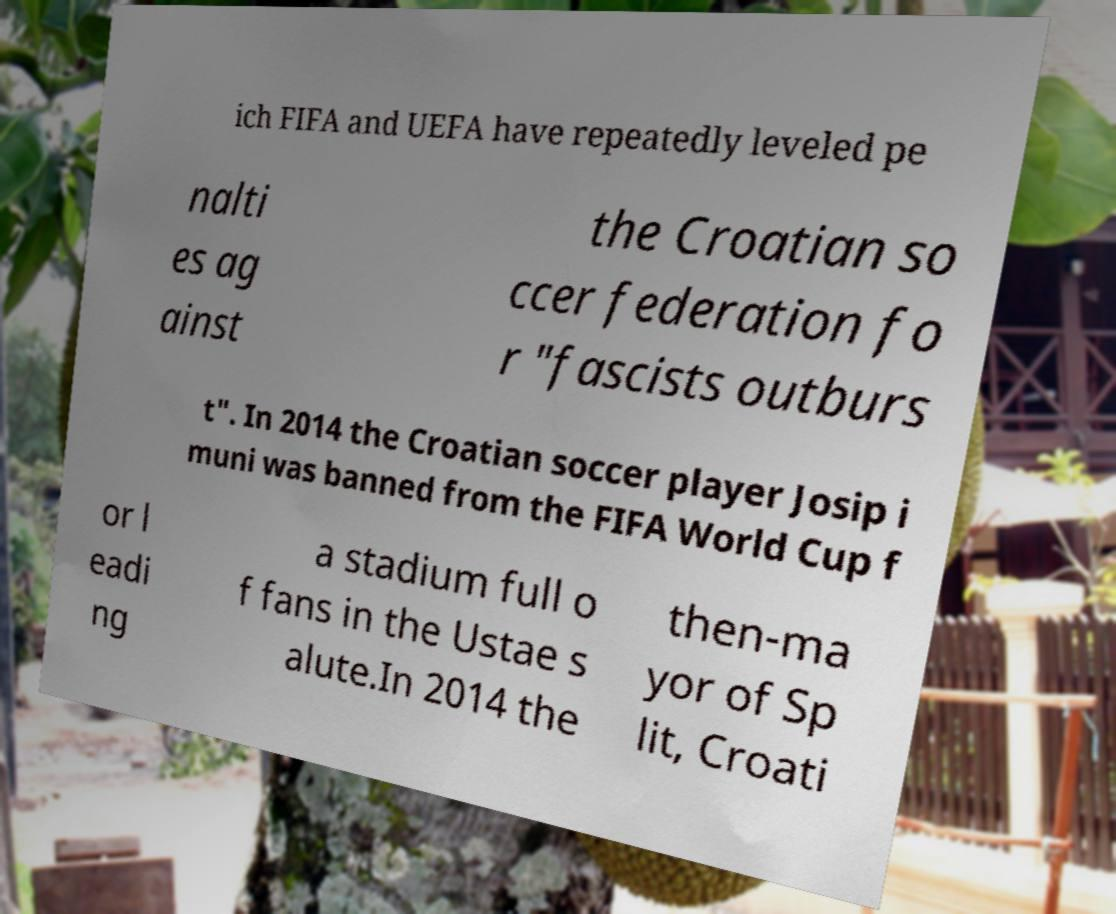Please read and relay the text visible in this image. What does it say? ich FIFA and UEFA have repeatedly leveled pe nalti es ag ainst the Croatian so ccer federation fo r "fascists outburs t". In 2014 the Croatian soccer player Josip i muni was banned from the FIFA World Cup f or l eadi ng a stadium full o f fans in the Ustae s alute.In 2014 the then-ma yor of Sp lit, Croati 